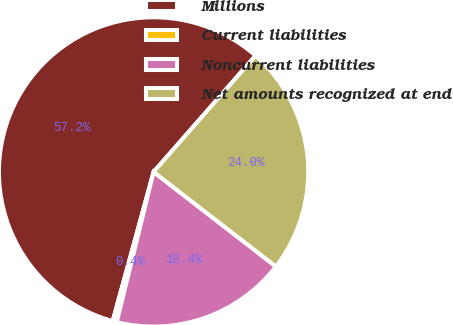Convert chart. <chart><loc_0><loc_0><loc_500><loc_500><pie_chart><fcel>Millions<fcel>Current liabilities<fcel>Noncurrent liabilities<fcel>Net amounts recognized at end<nl><fcel>57.2%<fcel>0.43%<fcel>18.35%<fcel>24.02%<nl></chart> 